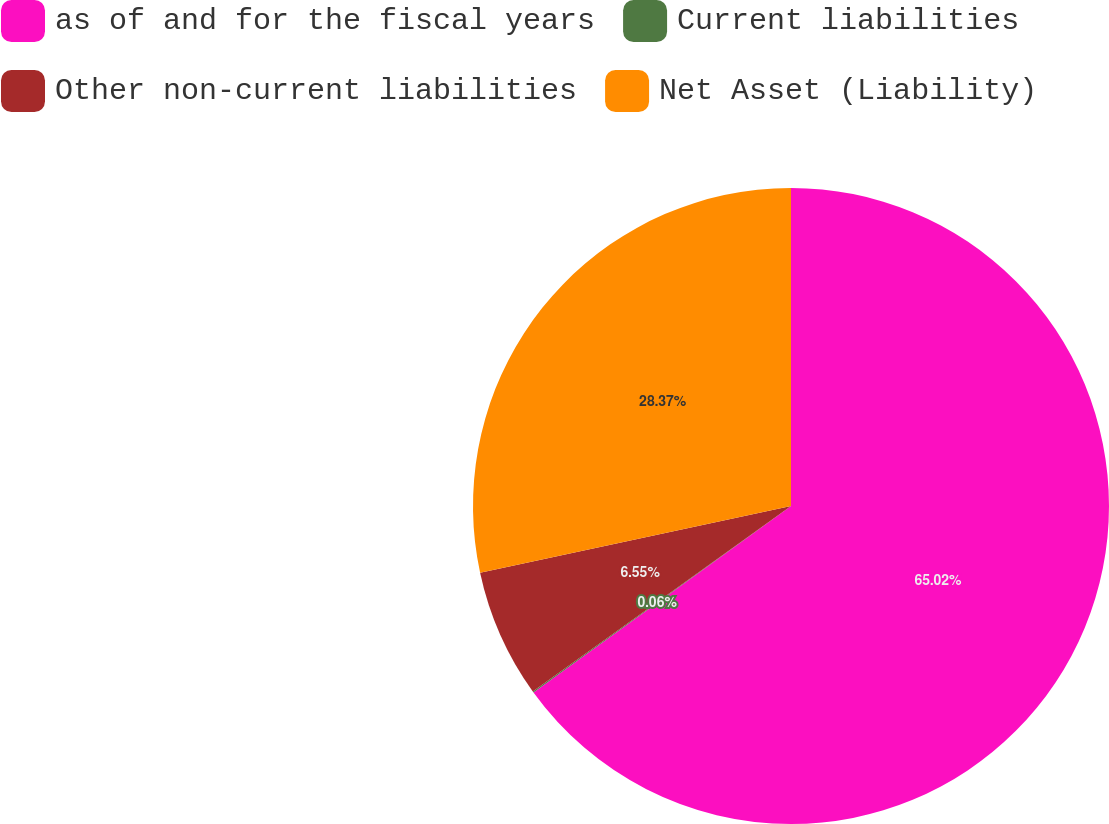<chart> <loc_0><loc_0><loc_500><loc_500><pie_chart><fcel>as of and for the fiscal years<fcel>Current liabilities<fcel>Other non-current liabilities<fcel>Net Asset (Liability)<nl><fcel>65.02%<fcel>0.06%<fcel>6.55%<fcel>28.37%<nl></chart> 